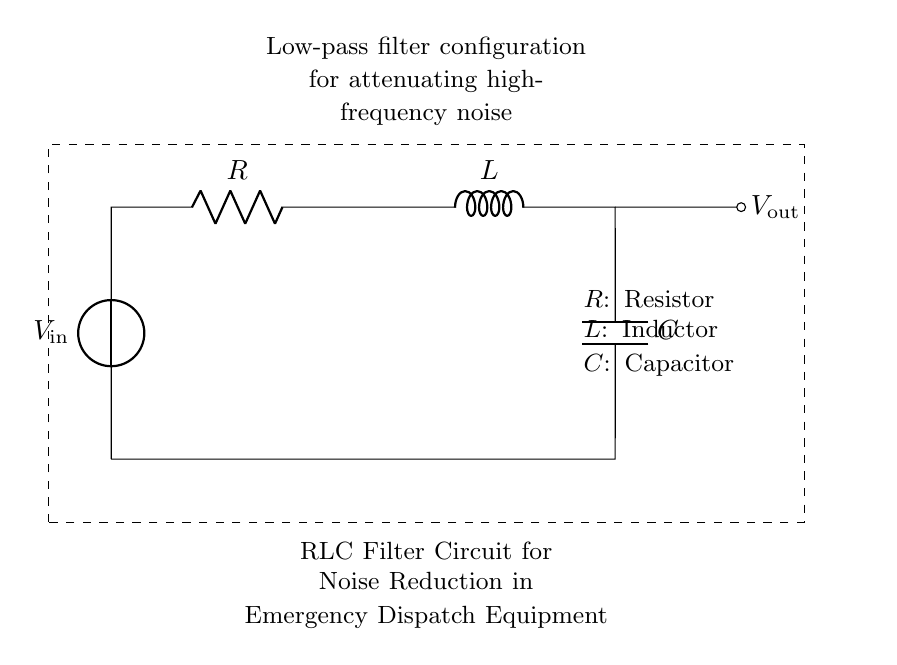What components are present in the circuit? The circuit consists of a resistor, an inductor, and a capacitor, which are labeled in the diagram.
Answer: Resistor, Inductor, Capacitor What is the purpose of this RLC filter circuit? The circuit is designed as a low-pass filter to attenuate high-frequency noise, as indicated in the diagram's description.
Answer: Noise reduction What is the type of this circuit configuration? The circuit is a low-pass filter configuration as specified, allowing low-frequency signals to pass while blocking high-frequency noise.
Answer: Low-pass filter Where does the output voltage measure in the circuit? The output voltage, labeled as "V_out," is measured across the capacitor, shown in the diagram.
Answer: Across the capacitor How does the inductor affect the circuit's frequency response? The inductor provides impedance to high-frequency signals, thus contributing to the filtering effect of the circuit, which reduces high-frequency noise.
Answer: Impedance to high frequencies What is the relationship between the resistor, inductor, and capacitor in this filter circuit? The resistor, inductor, and capacitor work together in series to form a filter, where each component influences the overall frequency response of the circuit.
Answer: Series connection influences frequency response 